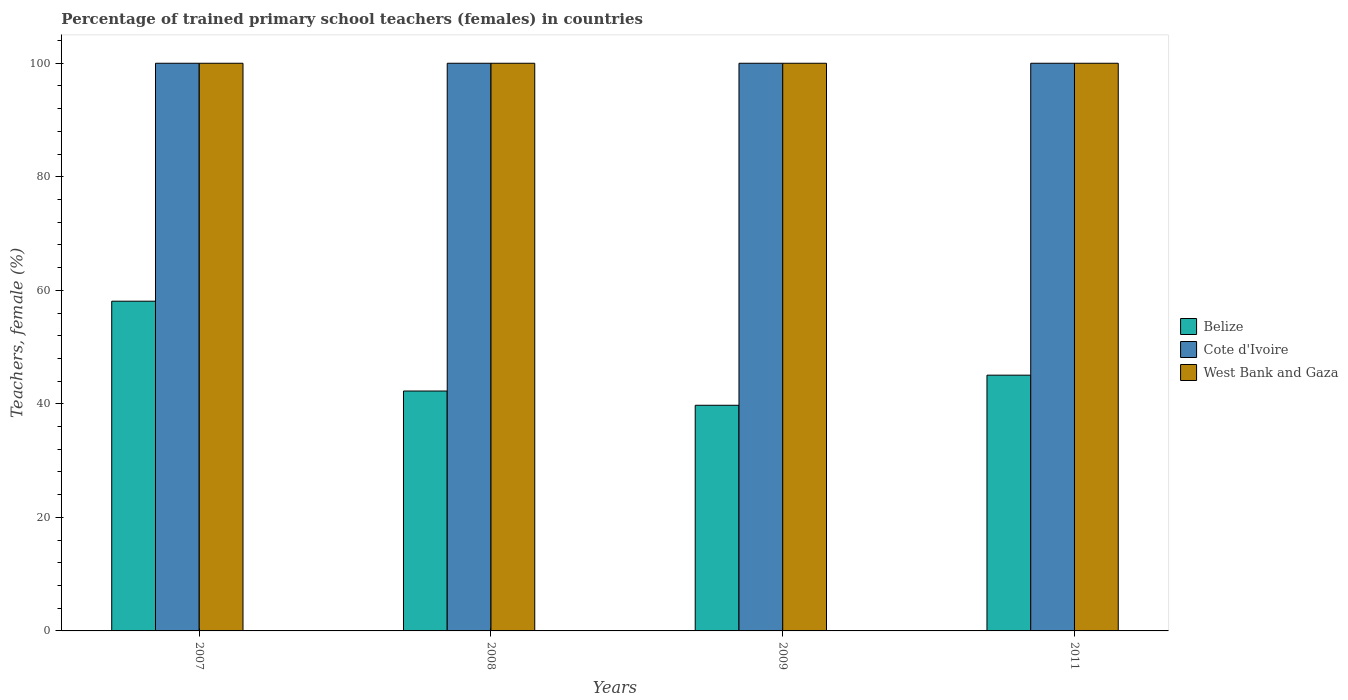How many different coloured bars are there?
Provide a short and direct response. 3. How many groups of bars are there?
Your answer should be compact. 4. Are the number of bars on each tick of the X-axis equal?
Keep it short and to the point. Yes. How many bars are there on the 1st tick from the left?
Make the answer very short. 3. What is the percentage of trained primary school teachers (females) in Cote d'Ivoire in 2007?
Offer a terse response. 100. Across all years, what is the minimum percentage of trained primary school teachers (females) in Belize?
Provide a short and direct response. 39.75. In which year was the percentage of trained primary school teachers (females) in Cote d'Ivoire maximum?
Provide a succinct answer. 2007. What is the total percentage of trained primary school teachers (females) in Cote d'Ivoire in the graph?
Make the answer very short. 400. What is the difference between the percentage of trained primary school teachers (females) in Cote d'Ivoire in 2008 and the percentage of trained primary school teachers (females) in Belize in 2011?
Keep it short and to the point. 54.95. What is the average percentage of trained primary school teachers (females) in Belize per year?
Give a very brief answer. 46.29. In the year 2008, what is the difference between the percentage of trained primary school teachers (females) in Cote d'Ivoire and percentage of trained primary school teachers (females) in West Bank and Gaza?
Provide a short and direct response. 0. In how many years, is the percentage of trained primary school teachers (females) in Belize greater than 48 %?
Offer a terse response. 1. What is the ratio of the percentage of trained primary school teachers (females) in Belize in 2008 to that in 2009?
Provide a short and direct response. 1.06. What is the difference between the highest and the second highest percentage of trained primary school teachers (females) in Belize?
Your response must be concise. 13.03. What is the difference between the highest and the lowest percentage of trained primary school teachers (females) in Cote d'Ivoire?
Ensure brevity in your answer.  0. What does the 3rd bar from the left in 2007 represents?
Your answer should be very brief. West Bank and Gaza. What does the 3rd bar from the right in 2011 represents?
Offer a very short reply. Belize. Is it the case that in every year, the sum of the percentage of trained primary school teachers (females) in Cote d'Ivoire and percentage of trained primary school teachers (females) in Belize is greater than the percentage of trained primary school teachers (females) in West Bank and Gaza?
Keep it short and to the point. Yes. How many bars are there?
Provide a succinct answer. 12. Are all the bars in the graph horizontal?
Your answer should be compact. No. How many years are there in the graph?
Make the answer very short. 4. What is the difference between two consecutive major ticks on the Y-axis?
Make the answer very short. 20. Are the values on the major ticks of Y-axis written in scientific E-notation?
Offer a very short reply. No. Does the graph contain any zero values?
Provide a short and direct response. No. How many legend labels are there?
Provide a succinct answer. 3. How are the legend labels stacked?
Offer a terse response. Vertical. What is the title of the graph?
Provide a short and direct response. Percentage of trained primary school teachers (females) in countries. What is the label or title of the X-axis?
Provide a succinct answer. Years. What is the label or title of the Y-axis?
Keep it short and to the point. Teachers, female (%). What is the Teachers, female (%) in Belize in 2007?
Your answer should be compact. 58.08. What is the Teachers, female (%) in West Bank and Gaza in 2007?
Provide a short and direct response. 100. What is the Teachers, female (%) of Belize in 2008?
Your answer should be very brief. 42.26. What is the Teachers, female (%) in Belize in 2009?
Keep it short and to the point. 39.75. What is the Teachers, female (%) of Belize in 2011?
Make the answer very short. 45.05. Across all years, what is the maximum Teachers, female (%) of Belize?
Make the answer very short. 58.08. Across all years, what is the minimum Teachers, female (%) of Belize?
Provide a short and direct response. 39.75. Across all years, what is the minimum Teachers, female (%) in Cote d'Ivoire?
Keep it short and to the point. 100. What is the total Teachers, female (%) of Belize in the graph?
Your answer should be compact. 185.15. What is the total Teachers, female (%) in Cote d'Ivoire in the graph?
Provide a succinct answer. 400. What is the difference between the Teachers, female (%) in Belize in 2007 and that in 2008?
Give a very brief answer. 15.82. What is the difference between the Teachers, female (%) in Cote d'Ivoire in 2007 and that in 2008?
Offer a terse response. 0. What is the difference between the Teachers, female (%) in West Bank and Gaza in 2007 and that in 2008?
Give a very brief answer. 0. What is the difference between the Teachers, female (%) of Belize in 2007 and that in 2009?
Provide a short and direct response. 18.33. What is the difference between the Teachers, female (%) of West Bank and Gaza in 2007 and that in 2009?
Offer a very short reply. 0. What is the difference between the Teachers, female (%) of Belize in 2007 and that in 2011?
Ensure brevity in your answer.  13.03. What is the difference between the Teachers, female (%) of Cote d'Ivoire in 2007 and that in 2011?
Offer a very short reply. 0. What is the difference between the Teachers, female (%) in Belize in 2008 and that in 2009?
Give a very brief answer. 2.51. What is the difference between the Teachers, female (%) in West Bank and Gaza in 2008 and that in 2009?
Keep it short and to the point. 0. What is the difference between the Teachers, female (%) in Belize in 2008 and that in 2011?
Ensure brevity in your answer.  -2.79. What is the difference between the Teachers, female (%) of West Bank and Gaza in 2008 and that in 2011?
Ensure brevity in your answer.  0. What is the difference between the Teachers, female (%) of Belize in 2009 and that in 2011?
Keep it short and to the point. -5.3. What is the difference between the Teachers, female (%) of West Bank and Gaza in 2009 and that in 2011?
Your answer should be very brief. 0. What is the difference between the Teachers, female (%) of Belize in 2007 and the Teachers, female (%) of Cote d'Ivoire in 2008?
Offer a very short reply. -41.92. What is the difference between the Teachers, female (%) of Belize in 2007 and the Teachers, female (%) of West Bank and Gaza in 2008?
Offer a very short reply. -41.92. What is the difference between the Teachers, female (%) in Cote d'Ivoire in 2007 and the Teachers, female (%) in West Bank and Gaza in 2008?
Ensure brevity in your answer.  0. What is the difference between the Teachers, female (%) of Belize in 2007 and the Teachers, female (%) of Cote d'Ivoire in 2009?
Offer a very short reply. -41.92. What is the difference between the Teachers, female (%) in Belize in 2007 and the Teachers, female (%) in West Bank and Gaza in 2009?
Your response must be concise. -41.92. What is the difference between the Teachers, female (%) in Cote d'Ivoire in 2007 and the Teachers, female (%) in West Bank and Gaza in 2009?
Give a very brief answer. 0. What is the difference between the Teachers, female (%) of Belize in 2007 and the Teachers, female (%) of Cote d'Ivoire in 2011?
Your response must be concise. -41.92. What is the difference between the Teachers, female (%) in Belize in 2007 and the Teachers, female (%) in West Bank and Gaza in 2011?
Keep it short and to the point. -41.92. What is the difference between the Teachers, female (%) of Belize in 2008 and the Teachers, female (%) of Cote d'Ivoire in 2009?
Ensure brevity in your answer.  -57.74. What is the difference between the Teachers, female (%) in Belize in 2008 and the Teachers, female (%) in West Bank and Gaza in 2009?
Your answer should be very brief. -57.74. What is the difference between the Teachers, female (%) of Belize in 2008 and the Teachers, female (%) of Cote d'Ivoire in 2011?
Your response must be concise. -57.74. What is the difference between the Teachers, female (%) of Belize in 2008 and the Teachers, female (%) of West Bank and Gaza in 2011?
Ensure brevity in your answer.  -57.74. What is the difference between the Teachers, female (%) of Cote d'Ivoire in 2008 and the Teachers, female (%) of West Bank and Gaza in 2011?
Make the answer very short. 0. What is the difference between the Teachers, female (%) of Belize in 2009 and the Teachers, female (%) of Cote d'Ivoire in 2011?
Make the answer very short. -60.25. What is the difference between the Teachers, female (%) in Belize in 2009 and the Teachers, female (%) in West Bank and Gaza in 2011?
Give a very brief answer. -60.25. What is the average Teachers, female (%) of Belize per year?
Ensure brevity in your answer.  46.29. What is the average Teachers, female (%) in Cote d'Ivoire per year?
Ensure brevity in your answer.  100. What is the average Teachers, female (%) in West Bank and Gaza per year?
Make the answer very short. 100. In the year 2007, what is the difference between the Teachers, female (%) in Belize and Teachers, female (%) in Cote d'Ivoire?
Your answer should be compact. -41.92. In the year 2007, what is the difference between the Teachers, female (%) in Belize and Teachers, female (%) in West Bank and Gaza?
Ensure brevity in your answer.  -41.92. In the year 2008, what is the difference between the Teachers, female (%) in Belize and Teachers, female (%) in Cote d'Ivoire?
Provide a short and direct response. -57.74. In the year 2008, what is the difference between the Teachers, female (%) of Belize and Teachers, female (%) of West Bank and Gaza?
Provide a short and direct response. -57.74. In the year 2009, what is the difference between the Teachers, female (%) in Belize and Teachers, female (%) in Cote d'Ivoire?
Offer a very short reply. -60.25. In the year 2009, what is the difference between the Teachers, female (%) in Belize and Teachers, female (%) in West Bank and Gaza?
Make the answer very short. -60.25. In the year 2011, what is the difference between the Teachers, female (%) in Belize and Teachers, female (%) in Cote d'Ivoire?
Your response must be concise. -54.95. In the year 2011, what is the difference between the Teachers, female (%) of Belize and Teachers, female (%) of West Bank and Gaza?
Keep it short and to the point. -54.95. What is the ratio of the Teachers, female (%) of Belize in 2007 to that in 2008?
Keep it short and to the point. 1.37. What is the ratio of the Teachers, female (%) in Belize in 2007 to that in 2009?
Offer a very short reply. 1.46. What is the ratio of the Teachers, female (%) in Cote d'Ivoire in 2007 to that in 2009?
Your response must be concise. 1. What is the ratio of the Teachers, female (%) of West Bank and Gaza in 2007 to that in 2009?
Your answer should be very brief. 1. What is the ratio of the Teachers, female (%) in Belize in 2007 to that in 2011?
Provide a short and direct response. 1.29. What is the ratio of the Teachers, female (%) in Cote d'Ivoire in 2007 to that in 2011?
Make the answer very short. 1. What is the ratio of the Teachers, female (%) in Belize in 2008 to that in 2009?
Provide a succinct answer. 1.06. What is the ratio of the Teachers, female (%) of West Bank and Gaza in 2008 to that in 2009?
Keep it short and to the point. 1. What is the ratio of the Teachers, female (%) of Belize in 2008 to that in 2011?
Keep it short and to the point. 0.94. What is the ratio of the Teachers, female (%) in Cote d'Ivoire in 2008 to that in 2011?
Offer a terse response. 1. What is the ratio of the Teachers, female (%) of West Bank and Gaza in 2008 to that in 2011?
Give a very brief answer. 1. What is the ratio of the Teachers, female (%) in Belize in 2009 to that in 2011?
Keep it short and to the point. 0.88. What is the ratio of the Teachers, female (%) of West Bank and Gaza in 2009 to that in 2011?
Your answer should be compact. 1. What is the difference between the highest and the second highest Teachers, female (%) of Belize?
Offer a terse response. 13.03. What is the difference between the highest and the lowest Teachers, female (%) in Belize?
Your answer should be compact. 18.33. 